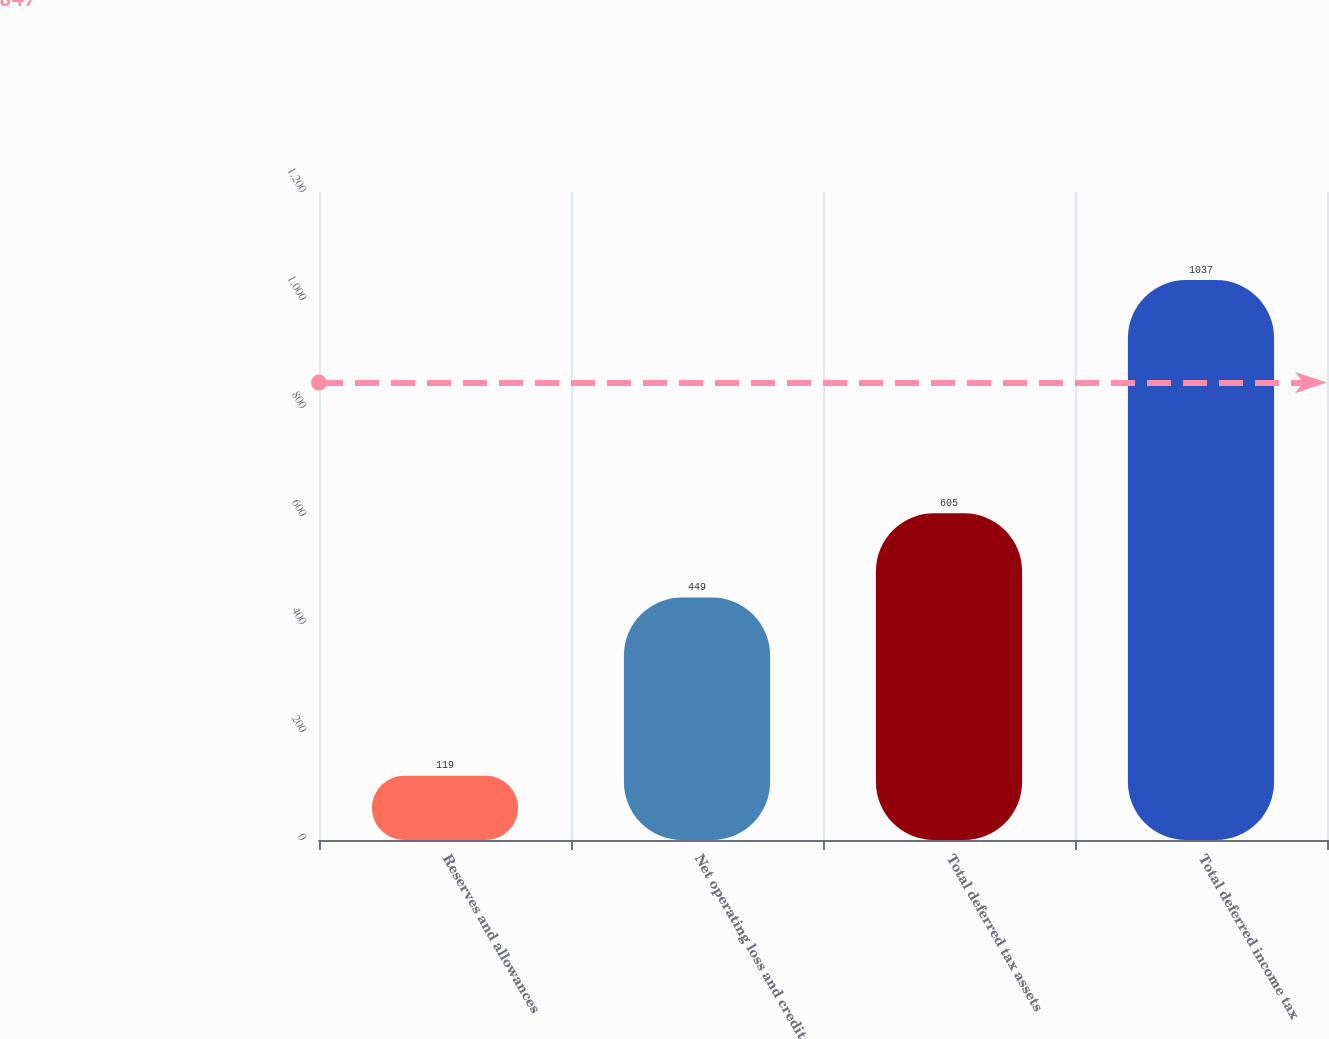<chart> <loc_0><loc_0><loc_500><loc_500><bar_chart><fcel>Reserves and allowances<fcel>Net operating loss and credit<fcel>Total deferred tax assets<fcel>Total deferred income tax<nl><fcel>119<fcel>449<fcel>605<fcel>1037<nl></chart> 